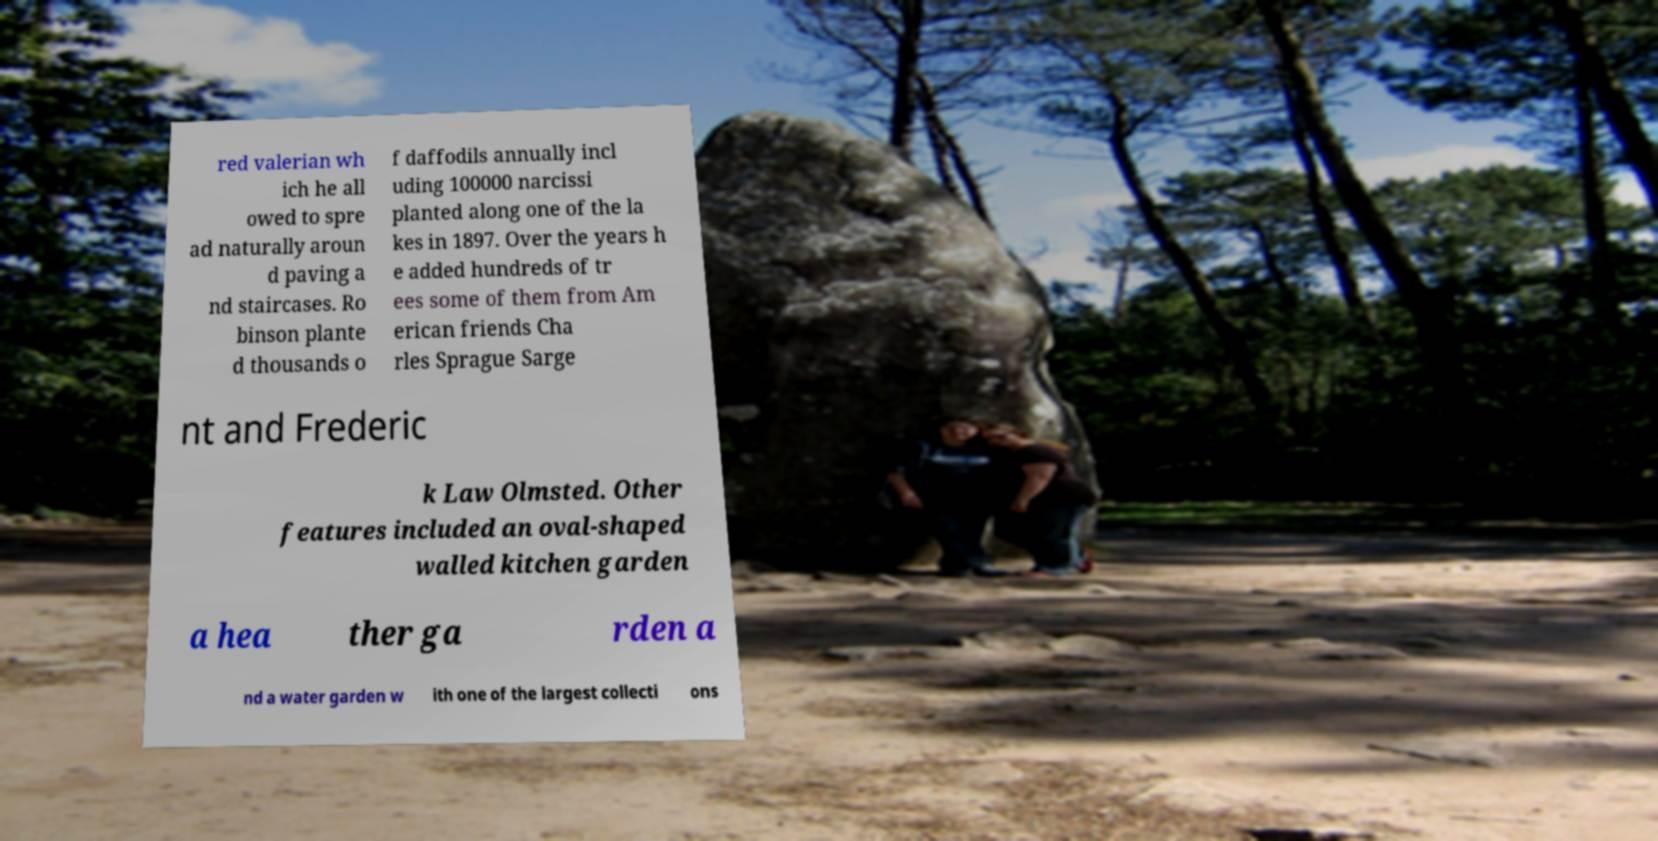I need the written content from this picture converted into text. Can you do that? red valerian wh ich he all owed to spre ad naturally aroun d paving a nd staircases. Ro binson plante d thousands o f daffodils annually incl uding 100000 narcissi planted along one of the la kes in 1897. Over the years h e added hundreds of tr ees some of them from Am erican friends Cha rles Sprague Sarge nt and Frederic k Law Olmsted. Other features included an oval-shaped walled kitchen garden a hea ther ga rden a nd a water garden w ith one of the largest collecti ons 